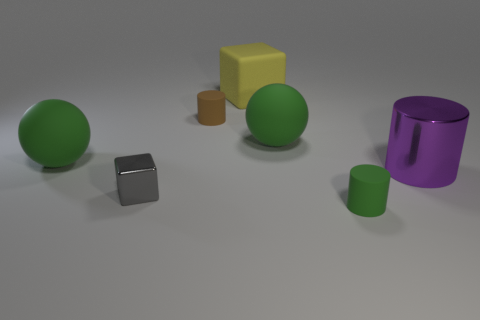Are there fewer blue balls than green cylinders?
Your response must be concise. Yes. There is a object that is both right of the tiny gray thing and in front of the large purple metallic thing; what shape is it?
Make the answer very short. Cylinder. The shiny object on the right side of the tiny metal cube in front of the large yellow matte block is what shape?
Your answer should be compact. Cylinder. Does the gray object have the same shape as the yellow matte object?
Offer a terse response. Yes. How many large green balls are left of the small rubber cylinder behind the cylinder that is in front of the small block?
Offer a very short reply. 1. The other small thing that is made of the same material as the small green object is what shape?
Give a very brief answer. Cylinder. There is a tiny cylinder that is on the left side of the tiny matte cylinder that is right of the rubber cylinder that is behind the tiny green matte thing; what is it made of?
Offer a very short reply. Rubber. How many objects are either rubber spheres that are on the right side of the gray shiny block or small metallic cubes?
Your answer should be compact. 2. What number of other things are there of the same shape as the small brown object?
Your answer should be compact. 2. Are there more brown matte objects right of the tiny gray metallic block than blue objects?
Keep it short and to the point. Yes. 